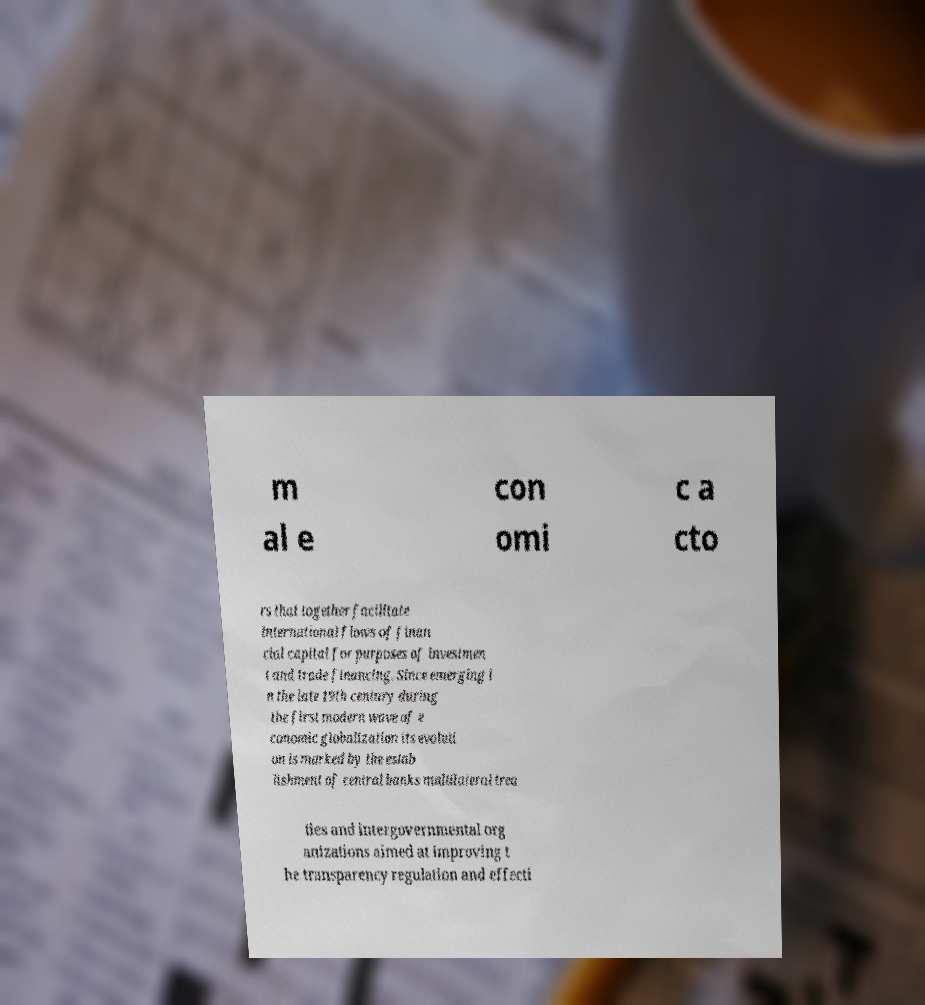I need the written content from this picture converted into text. Can you do that? m al e con omi c a cto rs that together facilitate international flows of finan cial capital for purposes of investmen t and trade financing. Since emerging i n the late 19th century during the first modern wave of e conomic globalization its evoluti on is marked by the estab lishment of central banks multilateral trea ties and intergovernmental org anizations aimed at improving t he transparency regulation and effecti 